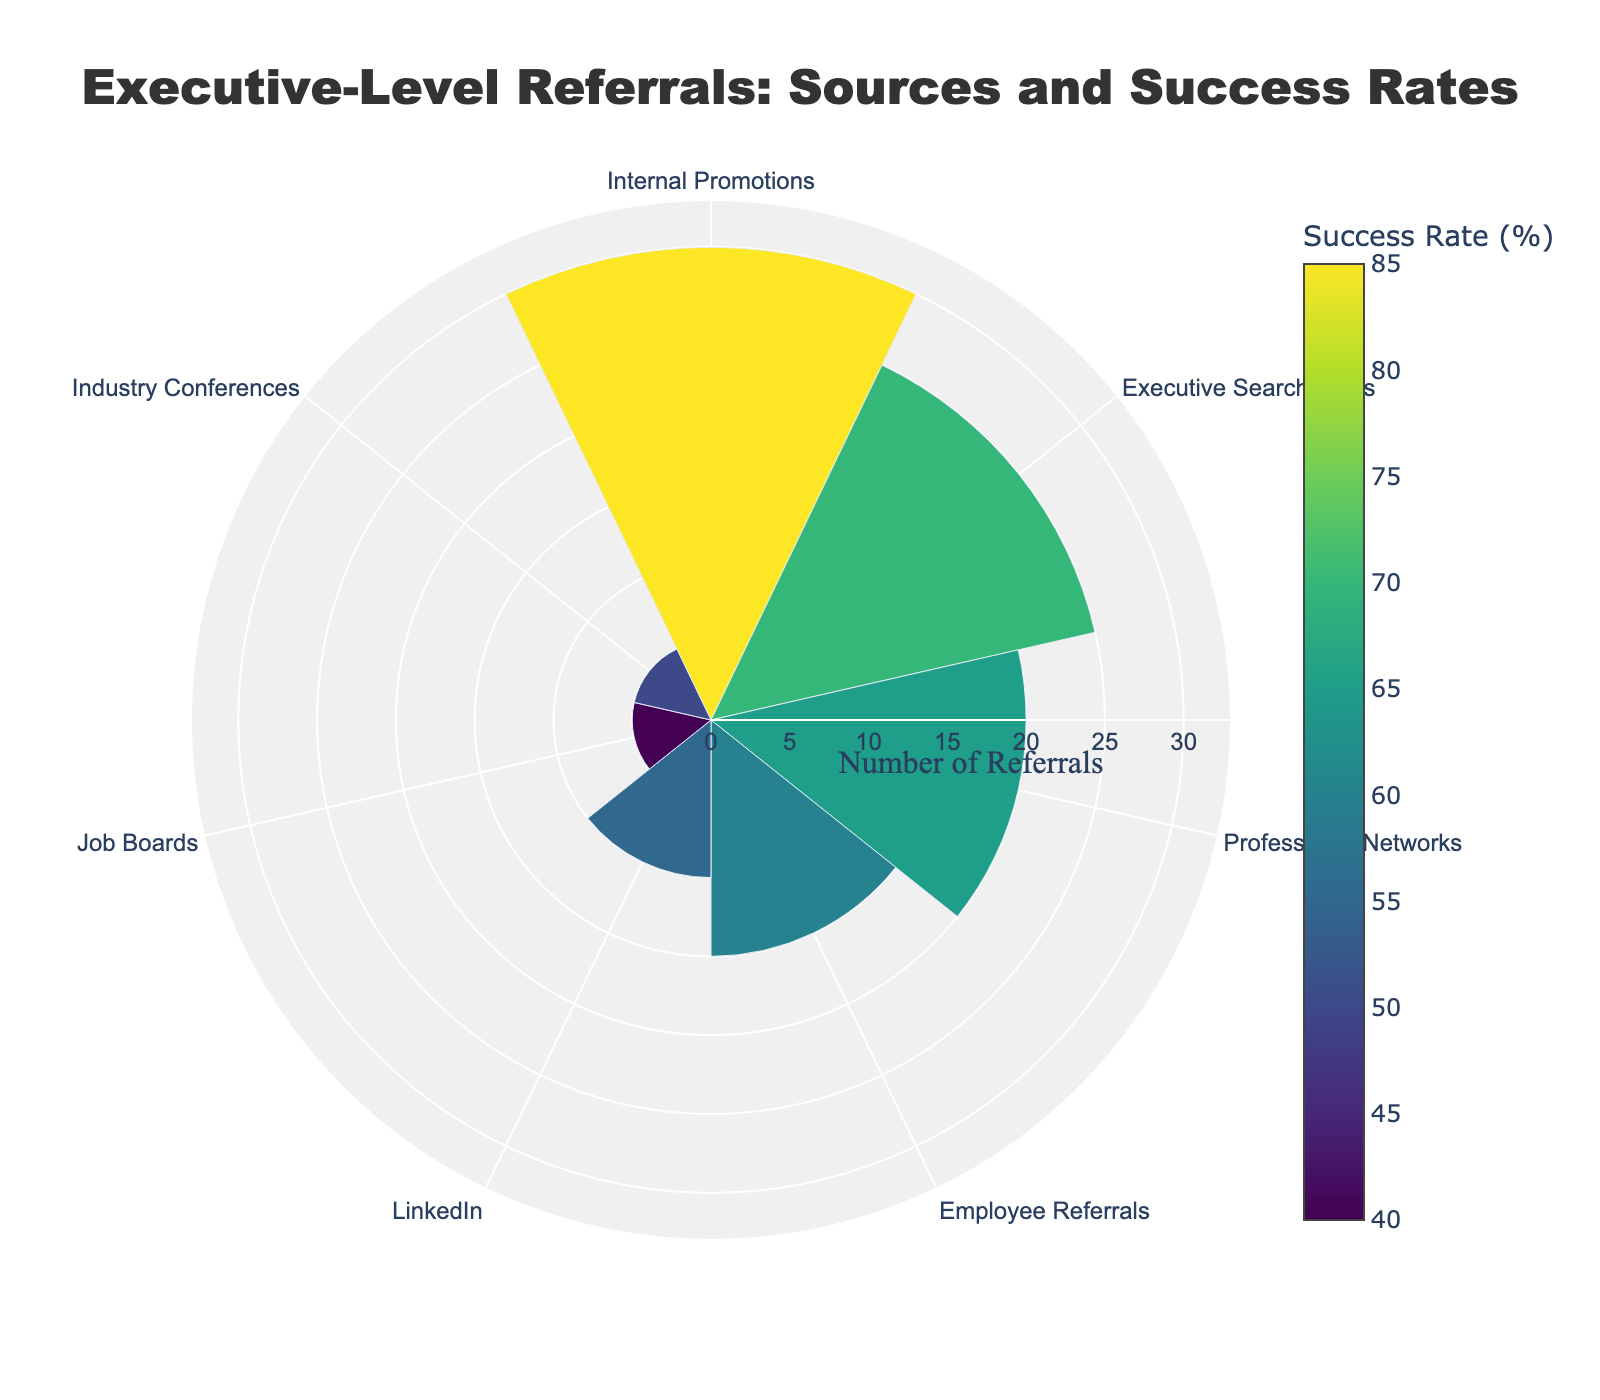Which source has the highest number of referrals? Refer to the largest segment in the polar area chart labeled with the number of referrals.
Answer: Internal Promotions What is the success rate for LinkedIn referrals? Identify the segment labeled "LinkedIn" and note the success rate provided in the hover text or its color intensity.
Answer: 55% Which source has the lowest success rate, and what is the value? Compare the intensity of the colors on the chart, with darker colors representing higher success rates. The lightest color will indicate the lowest success rate.
Answer: Job Boards, 40% What is the combined number of referrals from Employee Referrals and Industry Conferences? Find the segments labeled "Employee Referrals" and "Industry Conferences," then sum the number of referrals from each.
Answer: 15 + 5 = 20 How does the success rate of Executive Search Firms compare to Employee Referrals? Compare the color intensity and numerical success rates of the "Executive Search Firms" and "Employee Referrals" segments.
Answer: Executive Search Firms have a higher success rate (70%) compared to Employee Referrals (60%) What is the average success rate of all the sources combined? Sum the success rates of all sources and divide by the number of sources. Calculation: (85% + 70% + 65% + 60% + 55% + 40% + 50%) / 7 = 60.71%.
Answer: 60.71% Which source shows both a high number of referrals and a high success rate? Identify which segments have both a large size (high number of referrals) and a dark color (high success rate).
Answer: Internal Promotions Between Job Boards and Professional Networks, which source contributes more referrals? Compare the segments labeled "Job Boards" and "Professional Networks" to see which has a larger size representing more referrals.
Answer: Professional Networks What does the polar axis in the chart represent, and what is its range? Observe the labels on the radial axis. They provide the context for what is being measured (number of referrals) and the range (0 to approximately 33).
Answer: Number of referrals, 0 to 33 What does the angular axis in the chart represent, and how are the categories arranged? Review the text labels and arrangement around the chart's circumference; it shows the sources of referrals arranged in a clockwise direction.
Answer: Sources of referrals, clockwise direction 